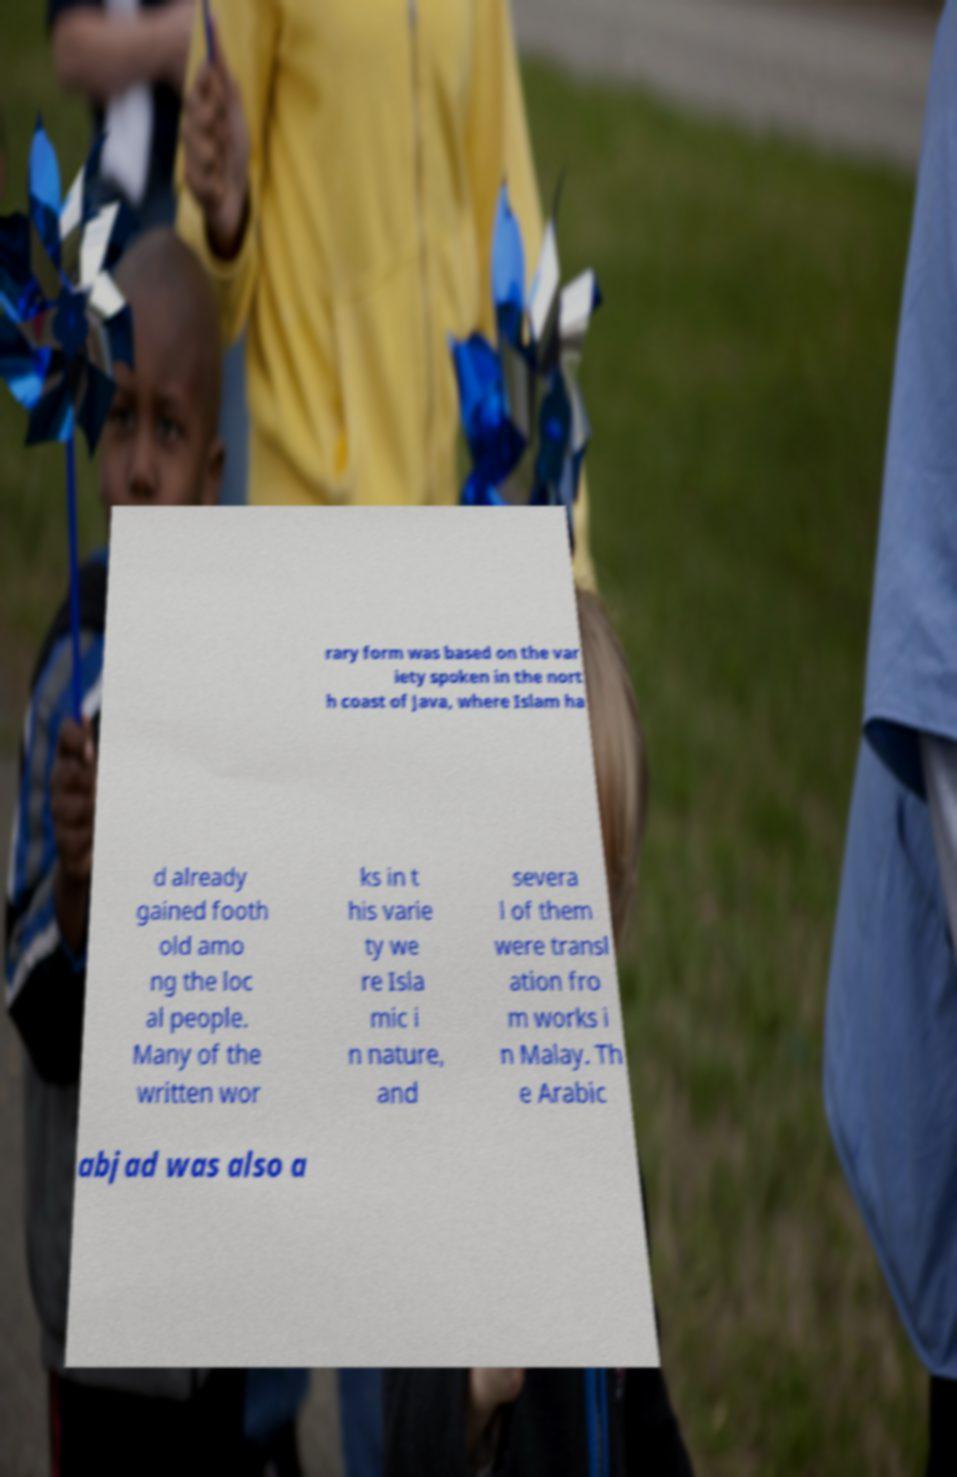Could you assist in decoding the text presented in this image and type it out clearly? rary form was based on the var iety spoken in the nort h coast of Java, where Islam ha d already gained footh old amo ng the loc al people. Many of the written wor ks in t his varie ty we re Isla mic i n nature, and severa l of them were transl ation fro m works i n Malay. Th e Arabic abjad was also a 